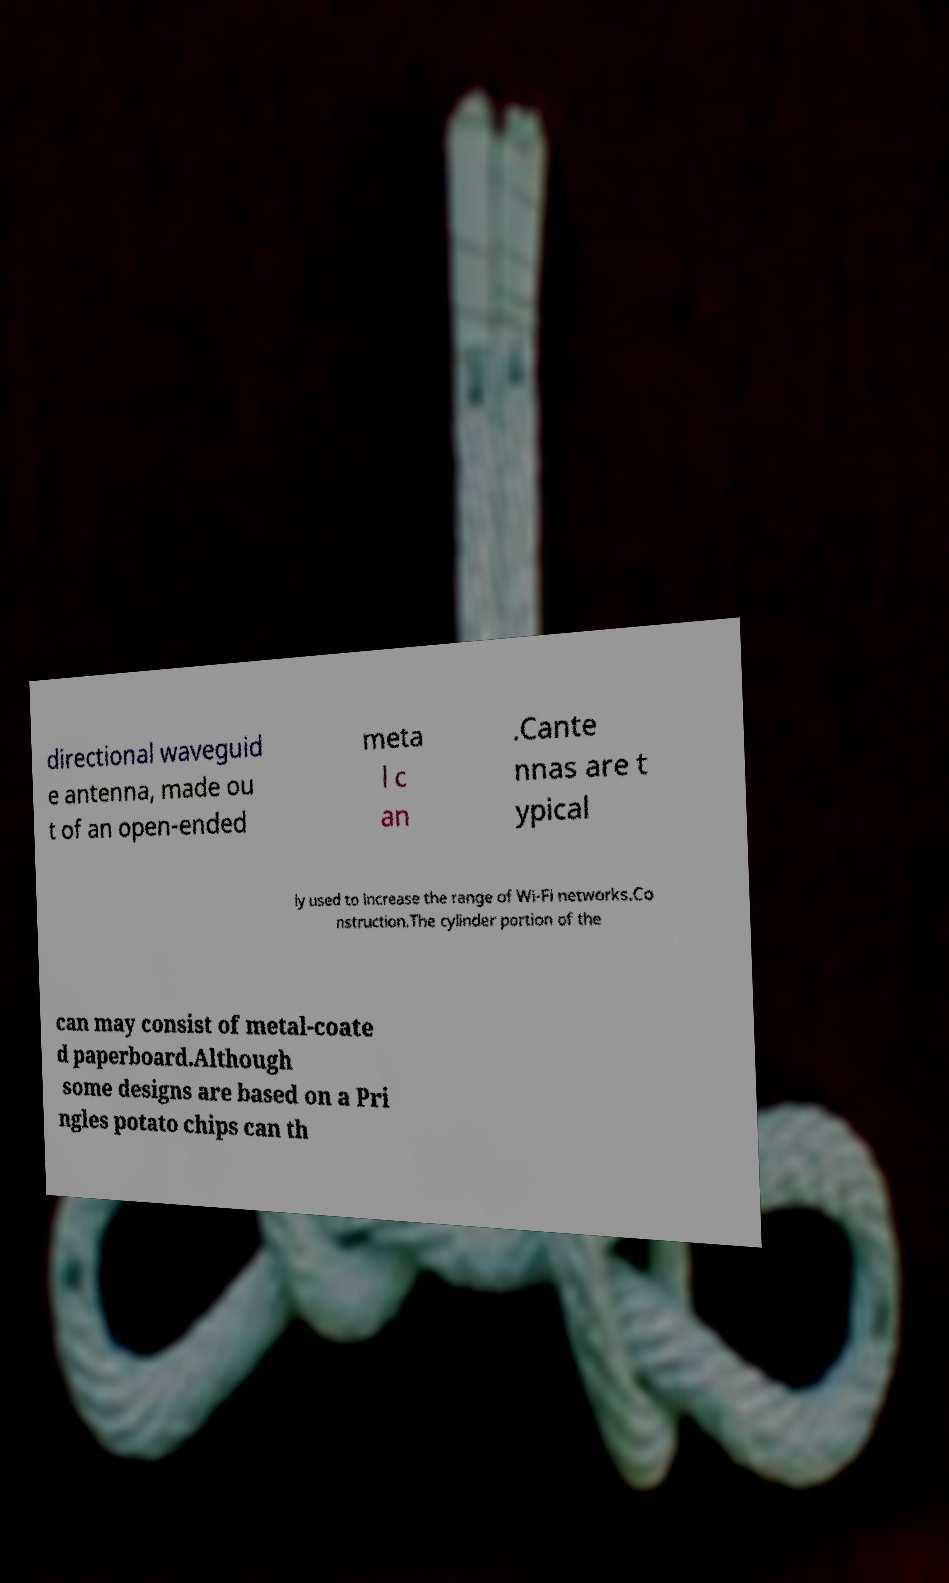Can you accurately transcribe the text from the provided image for me? directional waveguid e antenna, made ou t of an open-ended meta l c an .Cante nnas are t ypical ly used to increase the range of Wi-Fi networks.Co nstruction.The cylinder portion of the can may consist of metal-coate d paperboard.Although some designs are based on a Pri ngles potato chips can th 